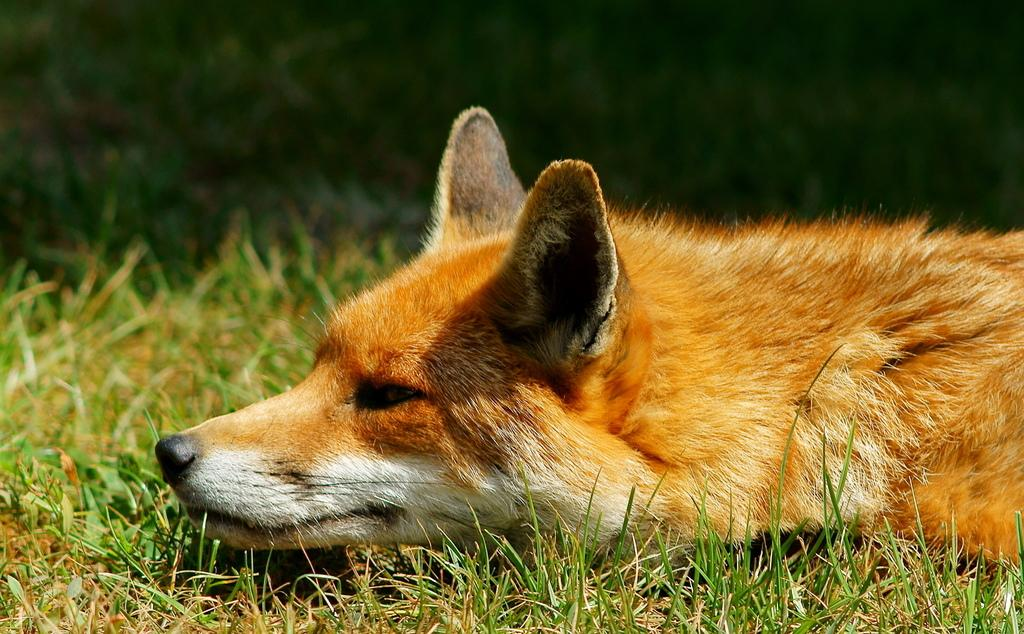What type of animal is in the image? There is a brown dog in the image. What is the dog doing in the image? The dog is laying on the grass. Where is the grass located in the image? The grass is on the ground. How would you describe the background of the image? The background of the image is dark in color. What type of government is depicted in the image? There is no depiction of a government in the image; it features a brown dog laying on the grass. How many oranges are visible in the image? There are no oranges present in the image. 